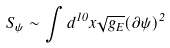<formula> <loc_0><loc_0><loc_500><loc_500>S _ { \psi } \sim \int d ^ { 1 0 } x \sqrt { g _ { E } } ( \partial \psi ) ^ { 2 }</formula> 